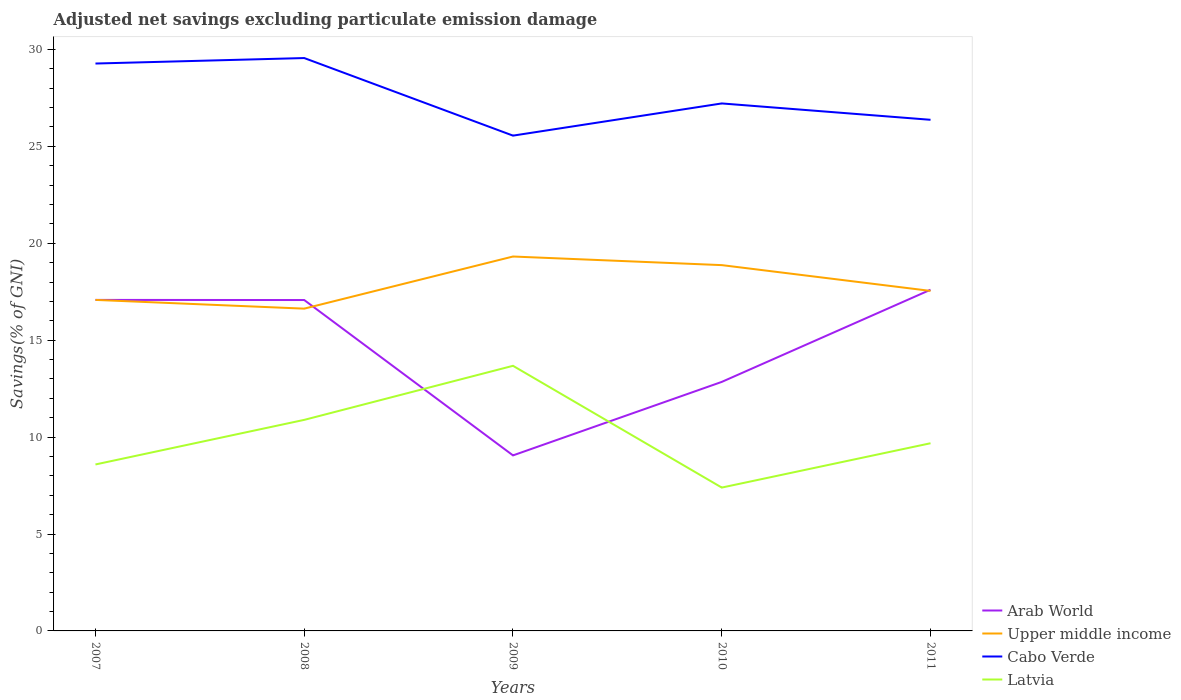Does the line corresponding to Cabo Verde intersect with the line corresponding to Arab World?
Your answer should be compact. No. Across all years, what is the maximum adjusted net savings in Arab World?
Offer a very short reply. 9.06. In which year was the adjusted net savings in Cabo Verde maximum?
Provide a succinct answer. 2009. What is the total adjusted net savings in Cabo Verde in the graph?
Give a very brief answer. -0.28. What is the difference between the highest and the second highest adjusted net savings in Latvia?
Give a very brief answer. 6.28. Is the adjusted net savings in Cabo Verde strictly greater than the adjusted net savings in Latvia over the years?
Your response must be concise. No. How many lines are there?
Make the answer very short. 4. How many years are there in the graph?
Offer a very short reply. 5. What is the difference between two consecutive major ticks on the Y-axis?
Provide a short and direct response. 5. Are the values on the major ticks of Y-axis written in scientific E-notation?
Offer a very short reply. No. Does the graph contain grids?
Ensure brevity in your answer.  No. Where does the legend appear in the graph?
Provide a succinct answer. Bottom right. What is the title of the graph?
Provide a short and direct response. Adjusted net savings excluding particulate emission damage. What is the label or title of the Y-axis?
Provide a short and direct response. Savings(% of GNI). What is the Savings(% of GNI) in Arab World in 2007?
Your response must be concise. 17.08. What is the Savings(% of GNI) in Upper middle income in 2007?
Ensure brevity in your answer.  17.08. What is the Savings(% of GNI) of Cabo Verde in 2007?
Your response must be concise. 29.27. What is the Savings(% of GNI) in Latvia in 2007?
Make the answer very short. 8.59. What is the Savings(% of GNI) in Arab World in 2008?
Offer a terse response. 17.07. What is the Savings(% of GNI) in Upper middle income in 2008?
Give a very brief answer. 16.63. What is the Savings(% of GNI) of Cabo Verde in 2008?
Give a very brief answer. 29.55. What is the Savings(% of GNI) in Latvia in 2008?
Keep it short and to the point. 10.89. What is the Savings(% of GNI) in Arab World in 2009?
Provide a short and direct response. 9.06. What is the Savings(% of GNI) of Upper middle income in 2009?
Ensure brevity in your answer.  19.32. What is the Savings(% of GNI) of Cabo Verde in 2009?
Provide a succinct answer. 25.55. What is the Savings(% of GNI) of Latvia in 2009?
Your response must be concise. 13.68. What is the Savings(% of GNI) of Arab World in 2010?
Keep it short and to the point. 12.85. What is the Savings(% of GNI) of Upper middle income in 2010?
Your answer should be compact. 18.87. What is the Savings(% of GNI) in Cabo Verde in 2010?
Ensure brevity in your answer.  27.21. What is the Savings(% of GNI) of Latvia in 2010?
Keep it short and to the point. 7.4. What is the Savings(% of GNI) of Arab World in 2011?
Provide a short and direct response. 17.6. What is the Savings(% of GNI) of Upper middle income in 2011?
Your answer should be very brief. 17.54. What is the Savings(% of GNI) in Cabo Verde in 2011?
Keep it short and to the point. 26.37. What is the Savings(% of GNI) in Latvia in 2011?
Your answer should be compact. 9.68. Across all years, what is the maximum Savings(% of GNI) of Arab World?
Provide a short and direct response. 17.6. Across all years, what is the maximum Savings(% of GNI) in Upper middle income?
Provide a succinct answer. 19.32. Across all years, what is the maximum Savings(% of GNI) of Cabo Verde?
Your answer should be very brief. 29.55. Across all years, what is the maximum Savings(% of GNI) of Latvia?
Your response must be concise. 13.68. Across all years, what is the minimum Savings(% of GNI) of Arab World?
Ensure brevity in your answer.  9.06. Across all years, what is the minimum Savings(% of GNI) of Upper middle income?
Offer a terse response. 16.63. Across all years, what is the minimum Savings(% of GNI) of Cabo Verde?
Provide a succinct answer. 25.55. Across all years, what is the minimum Savings(% of GNI) of Latvia?
Your answer should be very brief. 7.4. What is the total Savings(% of GNI) in Arab World in the graph?
Your answer should be very brief. 73.65. What is the total Savings(% of GNI) of Upper middle income in the graph?
Offer a terse response. 89.43. What is the total Savings(% of GNI) in Cabo Verde in the graph?
Your answer should be very brief. 137.96. What is the total Savings(% of GNI) of Latvia in the graph?
Offer a very short reply. 50.23. What is the difference between the Savings(% of GNI) of Arab World in 2007 and that in 2008?
Provide a short and direct response. 0.01. What is the difference between the Savings(% of GNI) in Upper middle income in 2007 and that in 2008?
Give a very brief answer. 0.45. What is the difference between the Savings(% of GNI) of Cabo Verde in 2007 and that in 2008?
Provide a succinct answer. -0.28. What is the difference between the Savings(% of GNI) of Latvia in 2007 and that in 2008?
Your response must be concise. -2.3. What is the difference between the Savings(% of GNI) of Arab World in 2007 and that in 2009?
Provide a succinct answer. 8.02. What is the difference between the Savings(% of GNI) of Upper middle income in 2007 and that in 2009?
Your response must be concise. -2.24. What is the difference between the Savings(% of GNI) of Cabo Verde in 2007 and that in 2009?
Offer a terse response. 3.72. What is the difference between the Savings(% of GNI) of Latvia in 2007 and that in 2009?
Provide a succinct answer. -5.09. What is the difference between the Savings(% of GNI) in Arab World in 2007 and that in 2010?
Keep it short and to the point. 4.23. What is the difference between the Savings(% of GNI) in Upper middle income in 2007 and that in 2010?
Ensure brevity in your answer.  -1.79. What is the difference between the Savings(% of GNI) of Cabo Verde in 2007 and that in 2010?
Offer a terse response. 2.06. What is the difference between the Savings(% of GNI) of Latvia in 2007 and that in 2010?
Provide a short and direct response. 1.19. What is the difference between the Savings(% of GNI) in Arab World in 2007 and that in 2011?
Make the answer very short. -0.52. What is the difference between the Savings(% of GNI) of Upper middle income in 2007 and that in 2011?
Provide a succinct answer. -0.46. What is the difference between the Savings(% of GNI) in Cabo Verde in 2007 and that in 2011?
Offer a very short reply. 2.9. What is the difference between the Savings(% of GNI) in Latvia in 2007 and that in 2011?
Provide a short and direct response. -1.09. What is the difference between the Savings(% of GNI) in Arab World in 2008 and that in 2009?
Provide a succinct answer. 8.02. What is the difference between the Savings(% of GNI) in Upper middle income in 2008 and that in 2009?
Offer a very short reply. -2.69. What is the difference between the Savings(% of GNI) in Cabo Verde in 2008 and that in 2009?
Your answer should be very brief. 4. What is the difference between the Savings(% of GNI) in Latvia in 2008 and that in 2009?
Your answer should be compact. -2.79. What is the difference between the Savings(% of GNI) of Arab World in 2008 and that in 2010?
Your answer should be very brief. 4.22. What is the difference between the Savings(% of GNI) of Upper middle income in 2008 and that in 2010?
Keep it short and to the point. -2.24. What is the difference between the Savings(% of GNI) in Cabo Verde in 2008 and that in 2010?
Your response must be concise. 2.34. What is the difference between the Savings(% of GNI) of Latvia in 2008 and that in 2010?
Offer a very short reply. 3.49. What is the difference between the Savings(% of GNI) in Arab World in 2008 and that in 2011?
Keep it short and to the point. -0.53. What is the difference between the Savings(% of GNI) of Upper middle income in 2008 and that in 2011?
Provide a succinct answer. -0.91. What is the difference between the Savings(% of GNI) of Cabo Verde in 2008 and that in 2011?
Your answer should be compact. 3.19. What is the difference between the Savings(% of GNI) in Latvia in 2008 and that in 2011?
Give a very brief answer. 1.21. What is the difference between the Savings(% of GNI) of Arab World in 2009 and that in 2010?
Your response must be concise. -3.79. What is the difference between the Savings(% of GNI) of Upper middle income in 2009 and that in 2010?
Offer a terse response. 0.44. What is the difference between the Savings(% of GNI) of Cabo Verde in 2009 and that in 2010?
Make the answer very short. -1.66. What is the difference between the Savings(% of GNI) of Latvia in 2009 and that in 2010?
Ensure brevity in your answer.  6.28. What is the difference between the Savings(% of GNI) of Arab World in 2009 and that in 2011?
Ensure brevity in your answer.  -8.55. What is the difference between the Savings(% of GNI) of Upper middle income in 2009 and that in 2011?
Offer a very short reply. 1.77. What is the difference between the Savings(% of GNI) in Cabo Verde in 2009 and that in 2011?
Offer a terse response. -0.82. What is the difference between the Savings(% of GNI) in Latvia in 2009 and that in 2011?
Ensure brevity in your answer.  3.99. What is the difference between the Savings(% of GNI) of Arab World in 2010 and that in 2011?
Keep it short and to the point. -4.75. What is the difference between the Savings(% of GNI) in Upper middle income in 2010 and that in 2011?
Offer a terse response. 1.33. What is the difference between the Savings(% of GNI) of Cabo Verde in 2010 and that in 2011?
Make the answer very short. 0.84. What is the difference between the Savings(% of GNI) of Latvia in 2010 and that in 2011?
Offer a terse response. -2.29. What is the difference between the Savings(% of GNI) of Arab World in 2007 and the Savings(% of GNI) of Upper middle income in 2008?
Give a very brief answer. 0.45. What is the difference between the Savings(% of GNI) of Arab World in 2007 and the Savings(% of GNI) of Cabo Verde in 2008?
Make the answer very short. -12.48. What is the difference between the Savings(% of GNI) in Arab World in 2007 and the Savings(% of GNI) in Latvia in 2008?
Provide a succinct answer. 6.19. What is the difference between the Savings(% of GNI) in Upper middle income in 2007 and the Savings(% of GNI) in Cabo Verde in 2008?
Make the answer very short. -12.48. What is the difference between the Savings(% of GNI) of Upper middle income in 2007 and the Savings(% of GNI) of Latvia in 2008?
Your answer should be compact. 6.19. What is the difference between the Savings(% of GNI) in Cabo Verde in 2007 and the Savings(% of GNI) in Latvia in 2008?
Your answer should be very brief. 18.38. What is the difference between the Savings(% of GNI) of Arab World in 2007 and the Savings(% of GNI) of Upper middle income in 2009?
Provide a short and direct response. -2.24. What is the difference between the Savings(% of GNI) of Arab World in 2007 and the Savings(% of GNI) of Cabo Verde in 2009?
Ensure brevity in your answer.  -8.48. What is the difference between the Savings(% of GNI) of Upper middle income in 2007 and the Savings(% of GNI) of Cabo Verde in 2009?
Provide a short and direct response. -8.48. What is the difference between the Savings(% of GNI) of Upper middle income in 2007 and the Savings(% of GNI) of Latvia in 2009?
Offer a very short reply. 3.4. What is the difference between the Savings(% of GNI) of Cabo Verde in 2007 and the Savings(% of GNI) of Latvia in 2009?
Ensure brevity in your answer.  15.59. What is the difference between the Savings(% of GNI) in Arab World in 2007 and the Savings(% of GNI) in Upper middle income in 2010?
Provide a short and direct response. -1.79. What is the difference between the Savings(% of GNI) of Arab World in 2007 and the Savings(% of GNI) of Cabo Verde in 2010?
Provide a succinct answer. -10.14. What is the difference between the Savings(% of GNI) of Arab World in 2007 and the Savings(% of GNI) of Latvia in 2010?
Make the answer very short. 9.68. What is the difference between the Savings(% of GNI) of Upper middle income in 2007 and the Savings(% of GNI) of Cabo Verde in 2010?
Make the answer very short. -10.14. What is the difference between the Savings(% of GNI) in Upper middle income in 2007 and the Savings(% of GNI) in Latvia in 2010?
Provide a succinct answer. 9.68. What is the difference between the Savings(% of GNI) of Cabo Verde in 2007 and the Savings(% of GNI) of Latvia in 2010?
Your response must be concise. 21.88. What is the difference between the Savings(% of GNI) in Arab World in 2007 and the Savings(% of GNI) in Upper middle income in 2011?
Make the answer very short. -0.46. What is the difference between the Savings(% of GNI) of Arab World in 2007 and the Savings(% of GNI) of Cabo Verde in 2011?
Provide a short and direct response. -9.29. What is the difference between the Savings(% of GNI) in Arab World in 2007 and the Savings(% of GNI) in Latvia in 2011?
Provide a succinct answer. 7.39. What is the difference between the Savings(% of GNI) of Upper middle income in 2007 and the Savings(% of GNI) of Cabo Verde in 2011?
Provide a succinct answer. -9.29. What is the difference between the Savings(% of GNI) in Upper middle income in 2007 and the Savings(% of GNI) in Latvia in 2011?
Your answer should be very brief. 7.39. What is the difference between the Savings(% of GNI) of Cabo Verde in 2007 and the Savings(% of GNI) of Latvia in 2011?
Your answer should be compact. 19.59. What is the difference between the Savings(% of GNI) in Arab World in 2008 and the Savings(% of GNI) in Upper middle income in 2009?
Provide a succinct answer. -2.24. What is the difference between the Savings(% of GNI) in Arab World in 2008 and the Savings(% of GNI) in Cabo Verde in 2009?
Your answer should be very brief. -8.48. What is the difference between the Savings(% of GNI) of Arab World in 2008 and the Savings(% of GNI) of Latvia in 2009?
Offer a very short reply. 3.39. What is the difference between the Savings(% of GNI) of Upper middle income in 2008 and the Savings(% of GNI) of Cabo Verde in 2009?
Give a very brief answer. -8.93. What is the difference between the Savings(% of GNI) of Upper middle income in 2008 and the Savings(% of GNI) of Latvia in 2009?
Provide a succinct answer. 2.95. What is the difference between the Savings(% of GNI) in Cabo Verde in 2008 and the Savings(% of GNI) in Latvia in 2009?
Provide a short and direct response. 15.88. What is the difference between the Savings(% of GNI) of Arab World in 2008 and the Savings(% of GNI) of Upper middle income in 2010?
Ensure brevity in your answer.  -1.8. What is the difference between the Savings(% of GNI) of Arab World in 2008 and the Savings(% of GNI) of Cabo Verde in 2010?
Offer a terse response. -10.14. What is the difference between the Savings(% of GNI) of Arab World in 2008 and the Savings(% of GNI) of Latvia in 2010?
Offer a terse response. 9.68. What is the difference between the Savings(% of GNI) of Upper middle income in 2008 and the Savings(% of GNI) of Cabo Verde in 2010?
Make the answer very short. -10.59. What is the difference between the Savings(% of GNI) in Upper middle income in 2008 and the Savings(% of GNI) in Latvia in 2010?
Make the answer very short. 9.23. What is the difference between the Savings(% of GNI) in Cabo Verde in 2008 and the Savings(% of GNI) in Latvia in 2010?
Provide a short and direct response. 22.16. What is the difference between the Savings(% of GNI) of Arab World in 2008 and the Savings(% of GNI) of Upper middle income in 2011?
Your answer should be compact. -0.47. What is the difference between the Savings(% of GNI) of Arab World in 2008 and the Savings(% of GNI) of Cabo Verde in 2011?
Ensure brevity in your answer.  -9.3. What is the difference between the Savings(% of GNI) of Arab World in 2008 and the Savings(% of GNI) of Latvia in 2011?
Keep it short and to the point. 7.39. What is the difference between the Savings(% of GNI) in Upper middle income in 2008 and the Savings(% of GNI) in Cabo Verde in 2011?
Keep it short and to the point. -9.74. What is the difference between the Savings(% of GNI) in Upper middle income in 2008 and the Savings(% of GNI) in Latvia in 2011?
Provide a succinct answer. 6.94. What is the difference between the Savings(% of GNI) of Cabo Verde in 2008 and the Savings(% of GNI) of Latvia in 2011?
Provide a succinct answer. 19.87. What is the difference between the Savings(% of GNI) of Arab World in 2009 and the Savings(% of GNI) of Upper middle income in 2010?
Give a very brief answer. -9.82. What is the difference between the Savings(% of GNI) in Arab World in 2009 and the Savings(% of GNI) in Cabo Verde in 2010?
Give a very brief answer. -18.16. What is the difference between the Savings(% of GNI) of Arab World in 2009 and the Savings(% of GNI) of Latvia in 2010?
Provide a succinct answer. 1.66. What is the difference between the Savings(% of GNI) in Upper middle income in 2009 and the Savings(% of GNI) in Cabo Verde in 2010?
Make the answer very short. -7.9. What is the difference between the Savings(% of GNI) of Upper middle income in 2009 and the Savings(% of GNI) of Latvia in 2010?
Give a very brief answer. 11.92. What is the difference between the Savings(% of GNI) of Cabo Verde in 2009 and the Savings(% of GNI) of Latvia in 2010?
Keep it short and to the point. 18.16. What is the difference between the Savings(% of GNI) in Arab World in 2009 and the Savings(% of GNI) in Upper middle income in 2011?
Make the answer very short. -8.49. What is the difference between the Savings(% of GNI) of Arab World in 2009 and the Savings(% of GNI) of Cabo Verde in 2011?
Your response must be concise. -17.31. What is the difference between the Savings(% of GNI) of Arab World in 2009 and the Savings(% of GNI) of Latvia in 2011?
Provide a short and direct response. -0.63. What is the difference between the Savings(% of GNI) of Upper middle income in 2009 and the Savings(% of GNI) of Cabo Verde in 2011?
Provide a short and direct response. -7.05. What is the difference between the Savings(% of GNI) in Upper middle income in 2009 and the Savings(% of GNI) in Latvia in 2011?
Your response must be concise. 9.63. What is the difference between the Savings(% of GNI) of Cabo Verde in 2009 and the Savings(% of GNI) of Latvia in 2011?
Make the answer very short. 15.87. What is the difference between the Savings(% of GNI) in Arab World in 2010 and the Savings(% of GNI) in Upper middle income in 2011?
Your response must be concise. -4.69. What is the difference between the Savings(% of GNI) in Arab World in 2010 and the Savings(% of GNI) in Cabo Verde in 2011?
Offer a very short reply. -13.52. What is the difference between the Savings(% of GNI) of Arab World in 2010 and the Savings(% of GNI) of Latvia in 2011?
Provide a short and direct response. 3.16. What is the difference between the Savings(% of GNI) in Upper middle income in 2010 and the Savings(% of GNI) in Cabo Verde in 2011?
Keep it short and to the point. -7.5. What is the difference between the Savings(% of GNI) of Upper middle income in 2010 and the Savings(% of GNI) of Latvia in 2011?
Your response must be concise. 9.19. What is the difference between the Savings(% of GNI) in Cabo Verde in 2010 and the Savings(% of GNI) in Latvia in 2011?
Give a very brief answer. 17.53. What is the average Savings(% of GNI) of Arab World per year?
Ensure brevity in your answer.  14.73. What is the average Savings(% of GNI) in Upper middle income per year?
Your answer should be very brief. 17.89. What is the average Savings(% of GNI) of Cabo Verde per year?
Your response must be concise. 27.59. What is the average Savings(% of GNI) of Latvia per year?
Ensure brevity in your answer.  10.05. In the year 2007, what is the difference between the Savings(% of GNI) in Arab World and Savings(% of GNI) in Upper middle income?
Give a very brief answer. 0. In the year 2007, what is the difference between the Savings(% of GNI) of Arab World and Savings(% of GNI) of Cabo Verde?
Give a very brief answer. -12.19. In the year 2007, what is the difference between the Savings(% of GNI) in Arab World and Savings(% of GNI) in Latvia?
Give a very brief answer. 8.49. In the year 2007, what is the difference between the Savings(% of GNI) of Upper middle income and Savings(% of GNI) of Cabo Verde?
Provide a succinct answer. -12.2. In the year 2007, what is the difference between the Savings(% of GNI) in Upper middle income and Savings(% of GNI) in Latvia?
Your answer should be very brief. 8.49. In the year 2007, what is the difference between the Savings(% of GNI) in Cabo Verde and Savings(% of GNI) in Latvia?
Offer a terse response. 20.68. In the year 2008, what is the difference between the Savings(% of GNI) in Arab World and Savings(% of GNI) in Upper middle income?
Ensure brevity in your answer.  0.44. In the year 2008, what is the difference between the Savings(% of GNI) of Arab World and Savings(% of GNI) of Cabo Verde?
Your answer should be very brief. -12.48. In the year 2008, what is the difference between the Savings(% of GNI) in Arab World and Savings(% of GNI) in Latvia?
Your answer should be very brief. 6.18. In the year 2008, what is the difference between the Savings(% of GNI) of Upper middle income and Savings(% of GNI) of Cabo Verde?
Your response must be concise. -12.93. In the year 2008, what is the difference between the Savings(% of GNI) in Upper middle income and Savings(% of GNI) in Latvia?
Give a very brief answer. 5.74. In the year 2008, what is the difference between the Savings(% of GNI) in Cabo Verde and Savings(% of GNI) in Latvia?
Provide a succinct answer. 18.67. In the year 2009, what is the difference between the Savings(% of GNI) in Arab World and Savings(% of GNI) in Upper middle income?
Offer a terse response. -10.26. In the year 2009, what is the difference between the Savings(% of GNI) of Arab World and Savings(% of GNI) of Cabo Verde?
Your response must be concise. -16.5. In the year 2009, what is the difference between the Savings(% of GNI) in Arab World and Savings(% of GNI) in Latvia?
Make the answer very short. -4.62. In the year 2009, what is the difference between the Savings(% of GNI) in Upper middle income and Savings(% of GNI) in Cabo Verde?
Your answer should be very brief. -6.24. In the year 2009, what is the difference between the Savings(% of GNI) in Upper middle income and Savings(% of GNI) in Latvia?
Your response must be concise. 5.64. In the year 2009, what is the difference between the Savings(% of GNI) in Cabo Verde and Savings(% of GNI) in Latvia?
Make the answer very short. 11.88. In the year 2010, what is the difference between the Savings(% of GNI) of Arab World and Savings(% of GNI) of Upper middle income?
Your response must be concise. -6.02. In the year 2010, what is the difference between the Savings(% of GNI) of Arab World and Savings(% of GNI) of Cabo Verde?
Offer a very short reply. -14.37. In the year 2010, what is the difference between the Savings(% of GNI) in Arab World and Savings(% of GNI) in Latvia?
Provide a short and direct response. 5.45. In the year 2010, what is the difference between the Savings(% of GNI) in Upper middle income and Savings(% of GNI) in Cabo Verde?
Keep it short and to the point. -8.34. In the year 2010, what is the difference between the Savings(% of GNI) in Upper middle income and Savings(% of GNI) in Latvia?
Your response must be concise. 11.48. In the year 2010, what is the difference between the Savings(% of GNI) in Cabo Verde and Savings(% of GNI) in Latvia?
Give a very brief answer. 19.82. In the year 2011, what is the difference between the Savings(% of GNI) in Arab World and Savings(% of GNI) in Upper middle income?
Offer a terse response. 0.06. In the year 2011, what is the difference between the Savings(% of GNI) in Arab World and Savings(% of GNI) in Cabo Verde?
Offer a very short reply. -8.77. In the year 2011, what is the difference between the Savings(% of GNI) of Arab World and Savings(% of GNI) of Latvia?
Provide a short and direct response. 7.92. In the year 2011, what is the difference between the Savings(% of GNI) in Upper middle income and Savings(% of GNI) in Cabo Verde?
Offer a terse response. -8.83. In the year 2011, what is the difference between the Savings(% of GNI) in Upper middle income and Savings(% of GNI) in Latvia?
Your answer should be compact. 7.86. In the year 2011, what is the difference between the Savings(% of GNI) of Cabo Verde and Savings(% of GNI) of Latvia?
Provide a succinct answer. 16.69. What is the ratio of the Savings(% of GNI) of Arab World in 2007 to that in 2008?
Give a very brief answer. 1. What is the ratio of the Savings(% of GNI) in Upper middle income in 2007 to that in 2008?
Offer a very short reply. 1.03. What is the ratio of the Savings(% of GNI) of Cabo Verde in 2007 to that in 2008?
Make the answer very short. 0.99. What is the ratio of the Savings(% of GNI) in Latvia in 2007 to that in 2008?
Give a very brief answer. 0.79. What is the ratio of the Savings(% of GNI) of Arab World in 2007 to that in 2009?
Your response must be concise. 1.89. What is the ratio of the Savings(% of GNI) in Upper middle income in 2007 to that in 2009?
Give a very brief answer. 0.88. What is the ratio of the Savings(% of GNI) of Cabo Verde in 2007 to that in 2009?
Offer a terse response. 1.15. What is the ratio of the Savings(% of GNI) in Latvia in 2007 to that in 2009?
Offer a terse response. 0.63. What is the ratio of the Savings(% of GNI) in Arab World in 2007 to that in 2010?
Offer a very short reply. 1.33. What is the ratio of the Savings(% of GNI) in Upper middle income in 2007 to that in 2010?
Give a very brief answer. 0.9. What is the ratio of the Savings(% of GNI) in Cabo Verde in 2007 to that in 2010?
Ensure brevity in your answer.  1.08. What is the ratio of the Savings(% of GNI) of Latvia in 2007 to that in 2010?
Your answer should be very brief. 1.16. What is the ratio of the Savings(% of GNI) of Arab World in 2007 to that in 2011?
Offer a very short reply. 0.97. What is the ratio of the Savings(% of GNI) of Upper middle income in 2007 to that in 2011?
Offer a very short reply. 0.97. What is the ratio of the Savings(% of GNI) in Cabo Verde in 2007 to that in 2011?
Provide a short and direct response. 1.11. What is the ratio of the Savings(% of GNI) of Latvia in 2007 to that in 2011?
Ensure brevity in your answer.  0.89. What is the ratio of the Savings(% of GNI) in Arab World in 2008 to that in 2009?
Ensure brevity in your answer.  1.89. What is the ratio of the Savings(% of GNI) in Upper middle income in 2008 to that in 2009?
Offer a very short reply. 0.86. What is the ratio of the Savings(% of GNI) of Cabo Verde in 2008 to that in 2009?
Give a very brief answer. 1.16. What is the ratio of the Savings(% of GNI) in Latvia in 2008 to that in 2009?
Give a very brief answer. 0.8. What is the ratio of the Savings(% of GNI) of Arab World in 2008 to that in 2010?
Your response must be concise. 1.33. What is the ratio of the Savings(% of GNI) of Upper middle income in 2008 to that in 2010?
Your response must be concise. 0.88. What is the ratio of the Savings(% of GNI) in Cabo Verde in 2008 to that in 2010?
Keep it short and to the point. 1.09. What is the ratio of the Savings(% of GNI) of Latvia in 2008 to that in 2010?
Offer a terse response. 1.47. What is the ratio of the Savings(% of GNI) in Arab World in 2008 to that in 2011?
Offer a terse response. 0.97. What is the ratio of the Savings(% of GNI) of Upper middle income in 2008 to that in 2011?
Keep it short and to the point. 0.95. What is the ratio of the Savings(% of GNI) in Cabo Verde in 2008 to that in 2011?
Your answer should be compact. 1.12. What is the ratio of the Savings(% of GNI) in Latvia in 2008 to that in 2011?
Give a very brief answer. 1.12. What is the ratio of the Savings(% of GNI) of Arab World in 2009 to that in 2010?
Keep it short and to the point. 0.7. What is the ratio of the Savings(% of GNI) of Upper middle income in 2009 to that in 2010?
Provide a short and direct response. 1.02. What is the ratio of the Savings(% of GNI) in Cabo Verde in 2009 to that in 2010?
Offer a very short reply. 0.94. What is the ratio of the Savings(% of GNI) in Latvia in 2009 to that in 2010?
Ensure brevity in your answer.  1.85. What is the ratio of the Savings(% of GNI) of Arab World in 2009 to that in 2011?
Ensure brevity in your answer.  0.51. What is the ratio of the Savings(% of GNI) in Upper middle income in 2009 to that in 2011?
Your answer should be very brief. 1.1. What is the ratio of the Savings(% of GNI) in Latvia in 2009 to that in 2011?
Your response must be concise. 1.41. What is the ratio of the Savings(% of GNI) in Arab World in 2010 to that in 2011?
Keep it short and to the point. 0.73. What is the ratio of the Savings(% of GNI) of Upper middle income in 2010 to that in 2011?
Provide a succinct answer. 1.08. What is the ratio of the Savings(% of GNI) of Cabo Verde in 2010 to that in 2011?
Offer a terse response. 1.03. What is the ratio of the Savings(% of GNI) in Latvia in 2010 to that in 2011?
Provide a succinct answer. 0.76. What is the difference between the highest and the second highest Savings(% of GNI) of Arab World?
Your answer should be compact. 0.52. What is the difference between the highest and the second highest Savings(% of GNI) of Upper middle income?
Offer a very short reply. 0.44. What is the difference between the highest and the second highest Savings(% of GNI) in Cabo Verde?
Offer a terse response. 0.28. What is the difference between the highest and the second highest Savings(% of GNI) of Latvia?
Ensure brevity in your answer.  2.79. What is the difference between the highest and the lowest Savings(% of GNI) in Arab World?
Your response must be concise. 8.55. What is the difference between the highest and the lowest Savings(% of GNI) of Upper middle income?
Make the answer very short. 2.69. What is the difference between the highest and the lowest Savings(% of GNI) of Cabo Verde?
Your answer should be very brief. 4. What is the difference between the highest and the lowest Savings(% of GNI) in Latvia?
Keep it short and to the point. 6.28. 